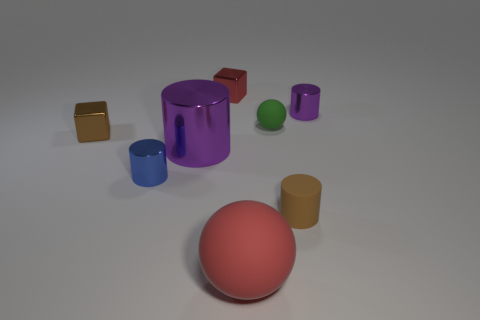Subtract all blue cylinders. How many cylinders are left? 3 Subtract 1 cylinders. How many cylinders are left? 3 Add 1 tiny brown cubes. How many objects exist? 9 Subtract all red cylinders. Subtract all gray spheres. How many cylinders are left? 4 Subtract all cubes. How many objects are left? 6 Add 7 large purple metal cylinders. How many large purple metal cylinders exist? 8 Subtract 0 yellow blocks. How many objects are left? 8 Subtract all tiny metallic cubes. Subtract all tiny brown things. How many objects are left? 4 Add 3 red matte objects. How many red matte objects are left? 4 